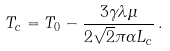Convert formula to latex. <formula><loc_0><loc_0><loc_500><loc_500>T _ { c } = T _ { 0 } - \frac { 3 \gamma \lambda \mu } { 2 \sqrt { 2 } \pi \alpha L _ { c } } \, .</formula> 